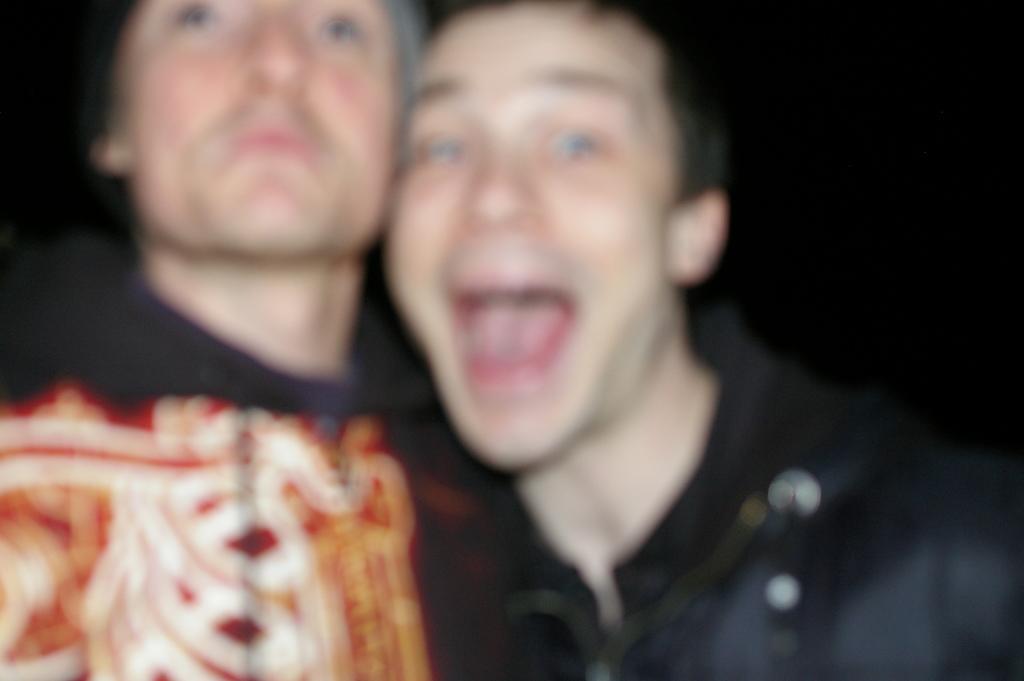Describe this image in one or two sentences. In this picture we can see blur picture, in it we can see two persons. 